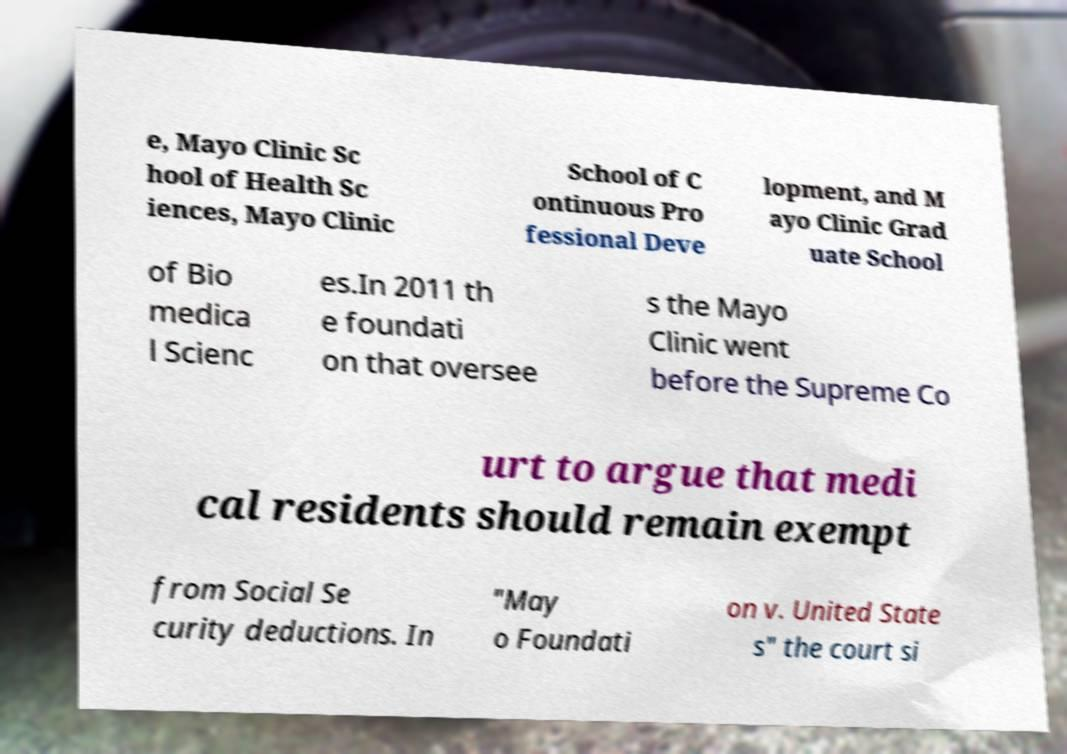What messages or text are displayed in this image? I need them in a readable, typed format. e, Mayo Clinic Sc hool of Health Sc iences, Mayo Clinic School of C ontinuous Pro fessional Deve lopment, and M ayo Clinic Grad uate School of Bio medica l Scienc es.In 2011 th e foundati on that oversee s the Mayo Clinic went before the Supreme Co urt to argue that medi cal residents should remain exempt from Social Se curity deductions. In "May o Foundati on v. United State s" the court si 